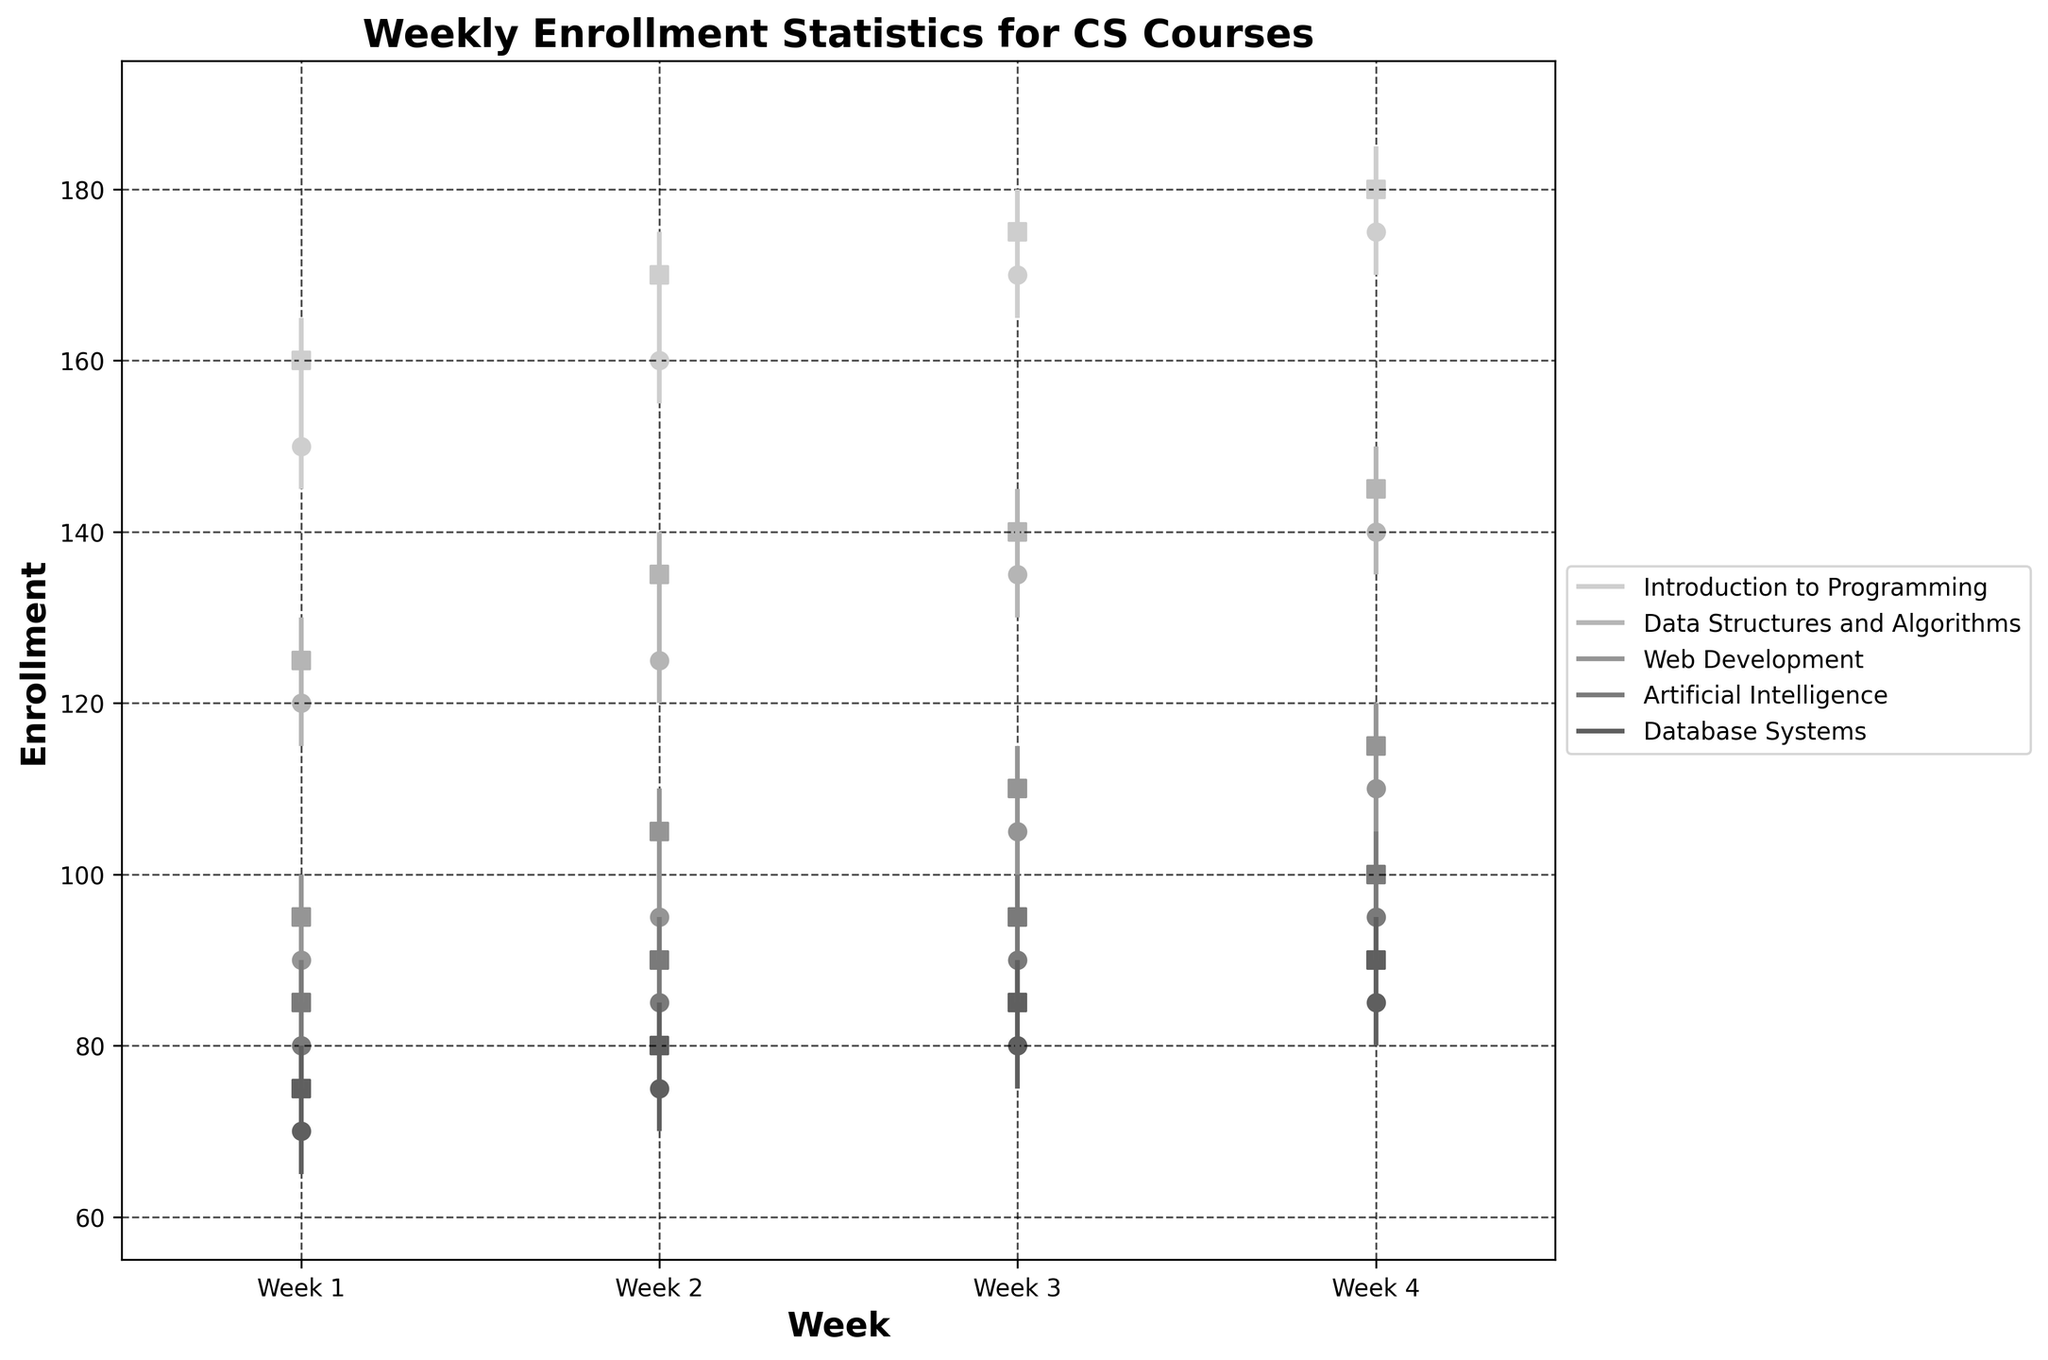What is the title of the chart? The chart title is typically shown at the top of the figure. In this case, the title is written as a large, bold text.
Answer: Weekly Enrollment Statistics for CS Courses Which course had the highest enrollment in the first week? By comparing the 'High' values for all courses for Week 1, we see that 'Introduction to Programming' has the highest value of 165.
Answer: Introduction to Programming Between which weeks did Web Development see the greatest increase in enrollment? By observing the 'Close' values of each week for Web Development, the largest increase happened between Week 1 (95) and Week 2 (105), an increase of 10 enrollments.
Answer: Week 1 to Week 2 What is the average closing enrollment for Data Structures and Algorithms over the four weeks? To find the average, sum the 'Close' values for each week (125 + 135 + 140 + 145) and divide by 4. This gives (125 + 135 + 140 + 145) / 4 = 136.25.
Answer: 136.25 Which course had the smallest difference between its lowest and highest enrollments in Week 3? The smallest difference can be found by subtracting 'Low' from 'High' in Week 3. Artificial Intelligence has the smallest difference: 100 - 85 = 15.
Answer: Artificial Intelligence How many courses had increasing enrollments every week? By checking each course's 'Close' values from Week 1 to Week 4, the courses with strictly increasing values are 'Introduction to Programming', 'Data Structures and Algorithms', and 'Web Development'. That's a total of 3 courses.
Answer: 3 Which week had the overall lowest enrollment among all courses? By checking the 'Low' values for each week across all courses, Week 1 of Database Systems has the lowest value of 65.
Answer: Week 1 What is the difference in enrollment between Week 1 and Week 4 for Artificial Intelligence? The 'Close' value for Week 1 is 85 and for Week 4 is 100. The difference is 100 - 85 = 15.
Answer: 15 Which course showed the most consistent weekly enrollment changes? The consistency of enrollment changes can be interpreted by looking at the differences in 'Close' values week over week. Artificial Intelligence had a consistent increase of 5 enrollments each week, indicating steady growth.
Answer: Artificial Intelligence 